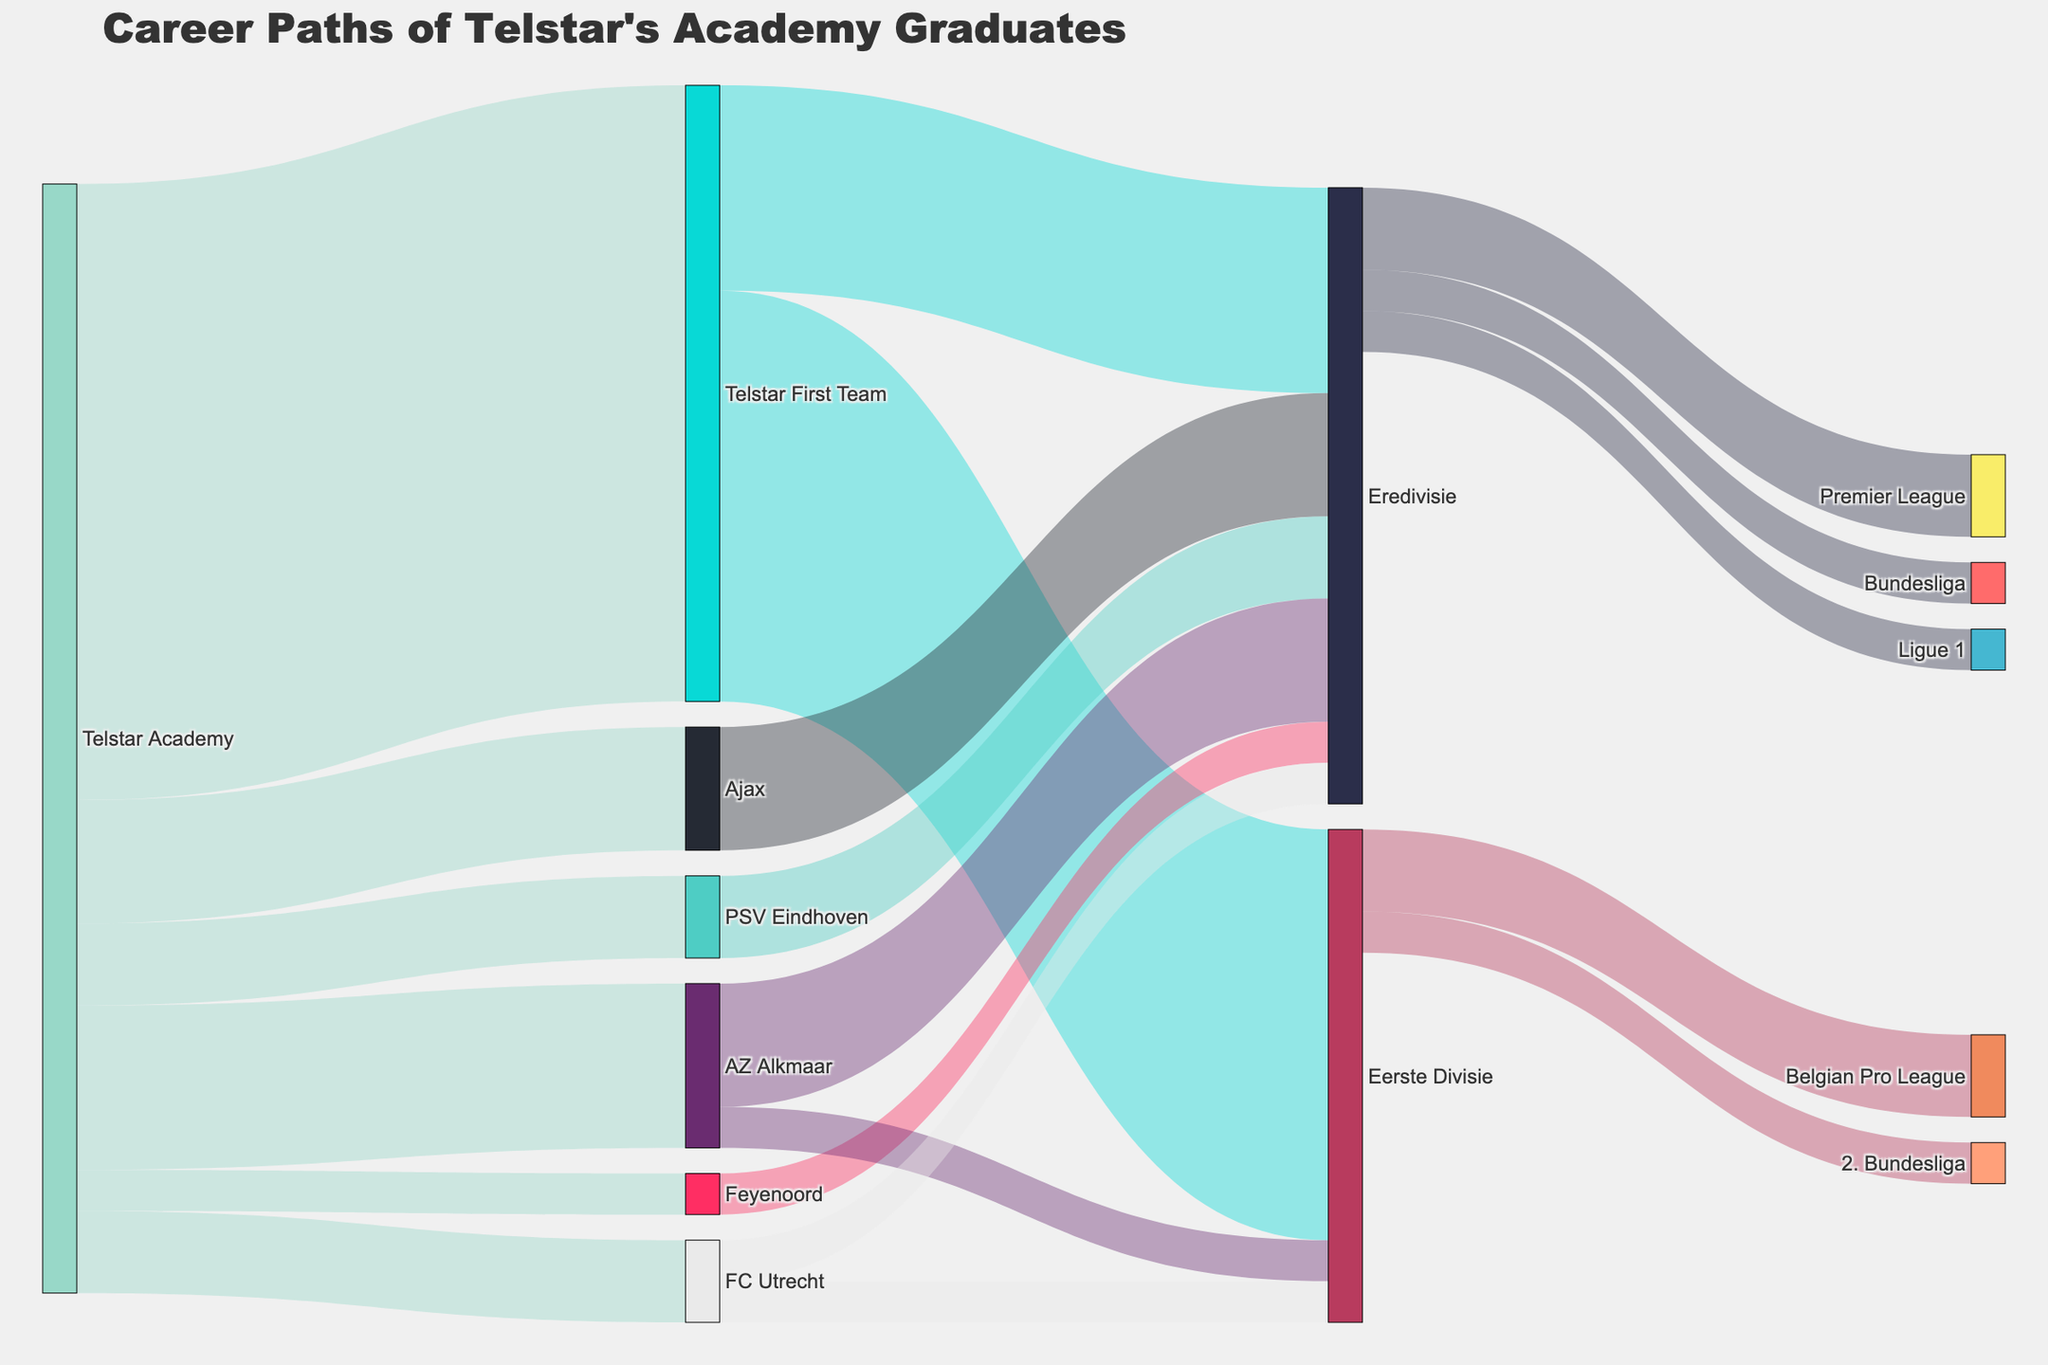What is the total number of players who moved directly to the Eredivisie from Telstar's academy? To find the total number of players who moved directly to the Eredivisie, we sum up the values from Telstar Academy to Ajax, PSV Eindhoven, Feyenoord, AZ Alkmaar, and FC Utrecht, all of which are Eredivisie clubs. These values are 3 (Ajax) + 2 (PSV Eindhoven) + 1 (Feyenoord) + 4 (AZ Alkmaar) + 2 (FC Utrecht), which sums to 12.
Answer: 12 How many players went from Telstar Academy to the Telstar First Team? We look for the flow directly connecting Telstar Academy to the Telstar First Team in the diagram and see that the value is 15.
Answer: 15 Which league did more players from the Telstar First Team move to, Eredivisie or Eerste Divisie? By comparing the flows from the Telstar First Team to Eredivisie and Eerste Divisie, we see that 5 players moved from the Telstar First Team to the Eredivisie, while 10 players moved to the Eerste Divisie. Thus, more players moved to the Eerste Divisie.
Answer: Eerste Divisie How many players from the Eredivisie moved on to foreign leagues? To find the total players from Eredivisie who moved to foreign leagues, we add the values for Premier League, Bundesliga, and Ligue 1. This is 2 (Premier League) + 1 (Bundesliga) + 1 (Ligue 1), which results in 4.
Answer: 4 How many players moved from AZ Alkmaar to Eerste Divisie compared to the number who moved to Eredivisie from AZ Alkmaar? We look at the values for the flows from AZ Alkmaar to both Eerste Divisie and Eredivisie. AZ Alkmaar to Eredivisie has 3 players, and AZ Alkmaar to Eerste Divisie has 1 player. So, more players went from AZ Alkmaar to Eredivisie than Eerste Divisie.
Answer: Eredivisie What is the total number of players who moved to the Eerste Divisie either from the Telstar First Team or from other Eredivisie clubs? Adding the values of the flows from Telstar First Team to Eerste Divisie and from FC Utrecht and AZ Alkmaar to Eerste Divisie, we get 10 (Telstar First Team) + 1 (FC Utrecht) + 1 (AZ Alkmaar), totaling 12 players.
Answer: 12 How many players transferred from the Eerste Divisie to foreign leagues? Summing the values for the flows from Eerste Divisie to Belgian Pro League and 2. Bundesliga, we get 2 (Belgian Pro League) + 1 (2. Bundesliga), totaling 3 players.
Answer: 3 Which club received the highest number of players from Telstar Academy? By comparing all the flows from Telstar Academy to various clubs, AZ Alkmaar received the most players with a value of 4.
Answer: AZ Alkmaar What is the overall number of players that graduated from Telstar’s academy and played in the Eerste Divisie at some point? Summing the direct flows to the Eerste Divisie and those who moved via other clubs’ first teams, we count 10 (Telstar First Team) + 1 (AZ Alkmaar) + 1 (FC Utrecht) = 12 players.
Answer: 12 How many stages of transitions are there from Telstar’s Academy to a foreign league (Premier League/Bundesliga/Ligue 1)? Considering one must move from Telstar Academy to either Eredivisie or Eerste Divisie first, and then to a foreign league, it involves two stages of transitions.
Answer: 2 